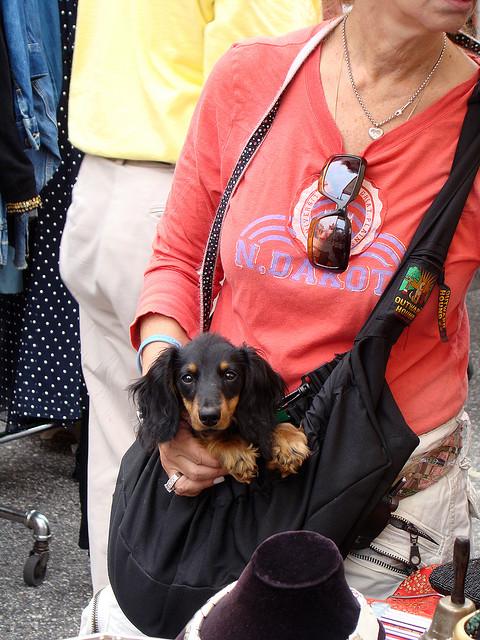Is a wheel visible?
Answer briefly. Yes. What state's name is on the woman's shirt?
Concise answer only. North dakota. What state is on this woman's shirt?
Keep it brief. North dakota. 